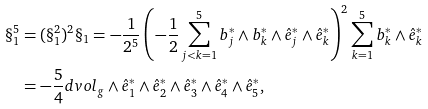<formula> <loc_0><loc_0><loc_500><loc_500>\S _ { 1 } ^ { 5 } & = ( \S _ { 1 } ^ { 2 } ) ^ { 2 } \S _ { 1 } = - \frac { 1 } { 2 ^ { 5 } } \left ( - \frac { 1 } { 2 } \sum _ { j < k = 1 } ^ { 5 } b _ { j } ^ { * } \wedge b _ { k } ^ { * } \wedge \hat { e } _ { j } ^ { * } \wedge \hat { e } _ { k } ^ { * } \right ) ^ { 2 } \sum _ { k = 1 } ^ { 5 } b ^ { * } _ { k } \wedge \hat { e } ^ { * } _ { k } \\ & = - \frac { 5 } { 4 } d v o l _ { g } \wedge \hat { e } _ { 1 } ^ { * } \wedge \hat { e } _ { 2 } ^ { * } \wedge \hat { e } _ { 3 } ^ { * } \wedge \hat { e } _ { 4 } ^ { * } \wedge \hat { e } _ { 5 } ^ { * } ,</formula> 